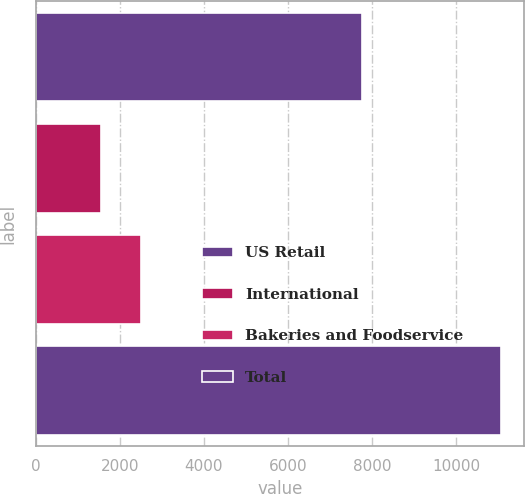<chart> <loc_0><loc_0><loc_500><loc_500><bar_chart><fcel>US Retail<fcel>International<fcel>Bakeries and Foodservice<fcel>Total<nl><fcel>7763<fcel>1550<fcel>2502<fcel>11070<nl></chart> 